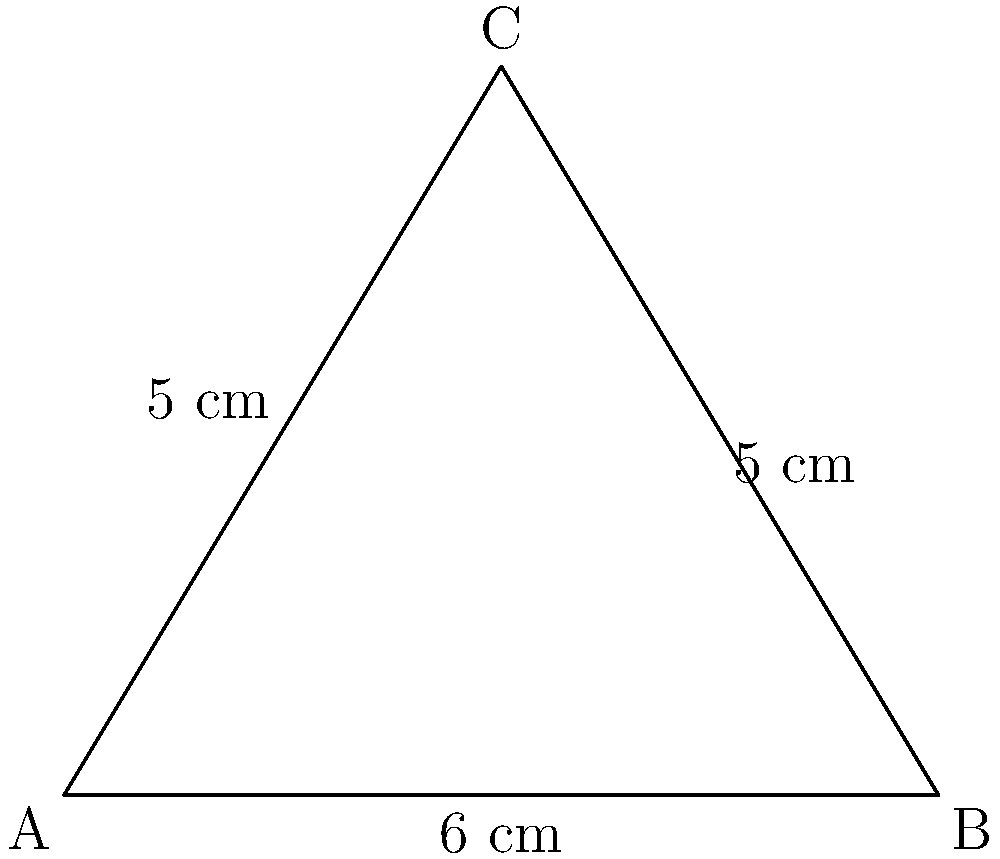At the garden club meeting, you're served a triangular slice of watermelon. The sides of the slice measure 5 cm, 5 cm, and 6 cm. What is the area of this delicious watermelon slice? To find the area of the triangular watermelon slice, we can use Heron's formula:

1) Heron's formula: $A = \sqrt{s(s-a)(s-b)(s-c)}$
   where $s$ is the semi-perimeter, and $a$, $b$, and $c$ are the side lengths.

2) Calculate the semi-perimeter:
   $s = \frac{a + b + c}{2} = \frac{5 + 5 + 6}{2} = \frac{16}{2} = 8$ cm

3) Substitute into Heron's formula:
   $A = \sqrt{8(8-5)(8-5)(8-6)}$
   $A = \sqrt{8 \cdot 3 \cdot 3 \cdot 2}$
   $A = \sqrt{144}$

4) Simplify:
   $A = 12$ cm²

Therefore, the area of the watermelon slice is 12 square centimeters.
Answer: 12 cm² 